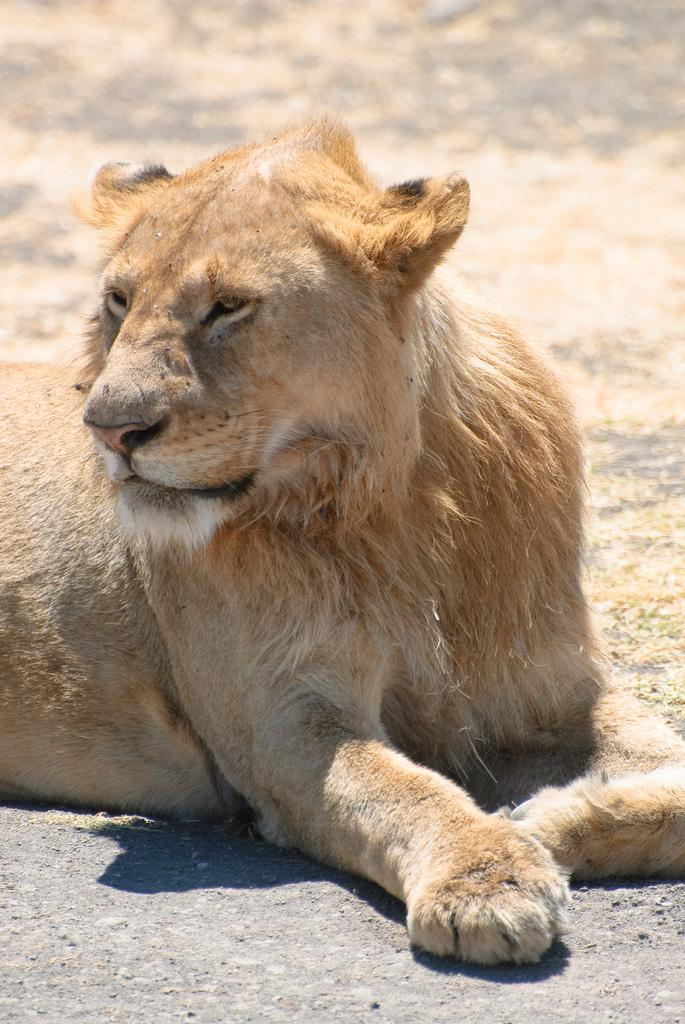What type of animal is in the image? There is a lion in the image. What type of chin does the lion have in the image? The image does not show the lion's chin, so it is not possible to answer that question. 